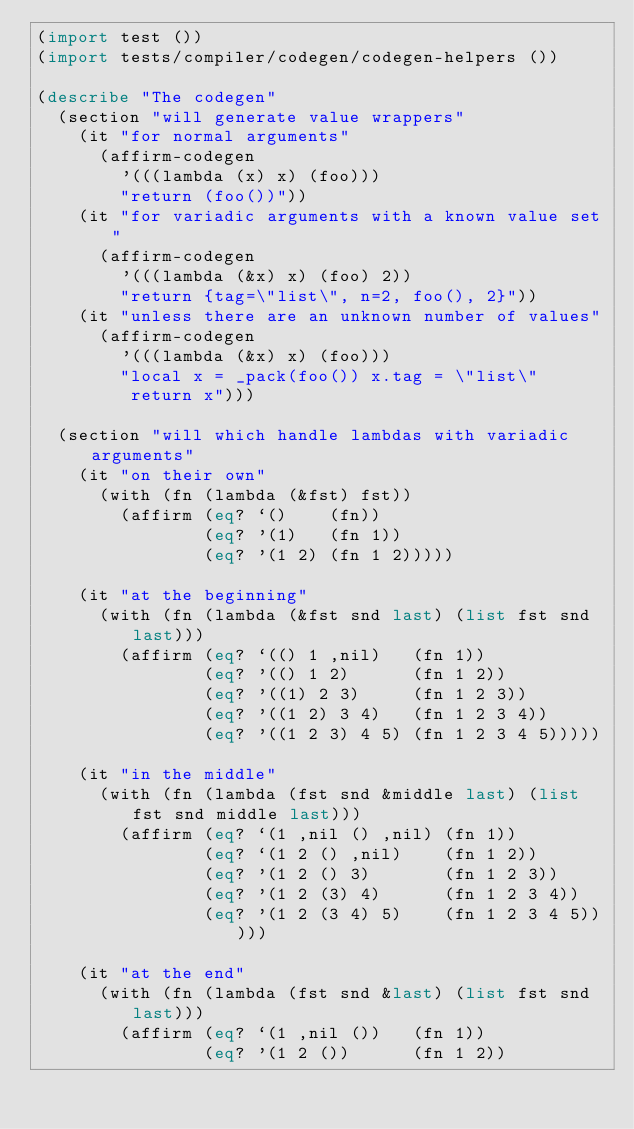<code> <loc_0><loc_0><loc_500><loc_500><_Lisp_>(import test ())
(import tests/compiler/codegen/codegen-helpers ())

(describe "The codegen"
  (section "will generate value wrappers"
    (it "for normal arguments"
      (affirm-codegen
        '(((lambda (x) x) (foo)))
        "return (foo())"))
    (it "for variadic arguments with a known value set"
      (affirm-codegen
        '(((lambda (&x) x) (foo) 2))
        "return {tag=\"list\", n=2, foo(), 2}"))
    (it "unless there are an unknown number of values"
      (affirm-codegen
        '(((lambda (&x) x) (foo)))
        "local x = _pack(foo()) x.tag = \"list\"
         return x")))

  (section "will which handle lambdas with variadic arguments"
    (it "on their own"
      (with (fn (lambda (&fst) fst))
        (affirm (eq? `()    (fn))
                (eq? '(1)   (fn 1))
                (eq? '(1 2) (fn 1 2)))))

    (it "at the beginning"
      (with (fn (lambda (&fst snd last) (list fst snd last)))
        (affirm (eq? `(() 1 ,nil)   (fn 1))
                (eq? '(() 1 2)      (fn 1 2))
                (eq? '((1) 2 3)     (fn 1 2 3))
                (eq? '((1 2) 3 4)   (fn 1 2 3 4))
                (eq? '((1 2 3) 4 5) (fn 1 2 3 4 5)))))

    (it "in the middle"
      (with (fn (lambda (fst snd &middle last) (list fst snd middle last)))
        (affirm (eq? `(1 ,nil () ,nil) (fn 1))
                (eq? `(1 2 () ,nil)    (fn 1 2))
                (eq? '(1 2 () 3)       (fn 1 2 3))
                (eq? '(1 2 (3) 4)      (fn 1 2 3 4))
                (eq? '(1 2 (3 4) 5)    (fn 1 2 3 4 5)))))

    (it "at the end"
      (with (fn (lambda (fst snd &last) (list fst snd last)))
        (affirm (eq? `(1 ,nil ())   (fn 1))
                (eq? '(1 2 ())      (fn 1 2))</code> 